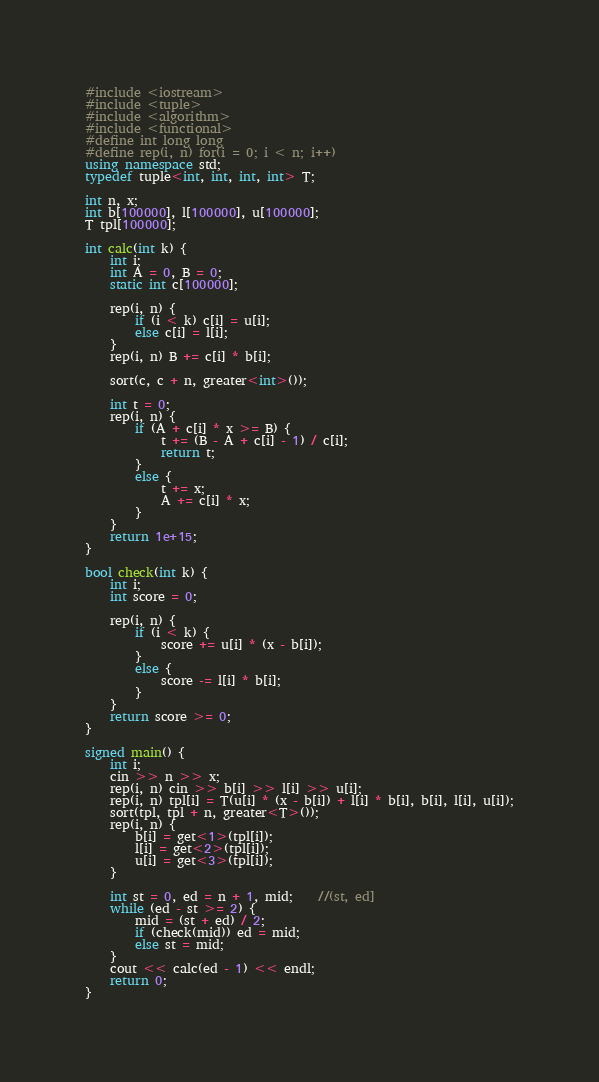Convert code to text. <code><loc_0><loc_0><loc_500><loc_500><_C++_>#include <iostream>
#include <tuple>
#include <algorithm>
#include <functional>
#define int long long
#define rep(i, n) for(i = 0; i < n; i++)
using namespace std;
typedef tuple<int, int, int, int> T;

int n, x;
int b[100000], l[100000], u[100000];
T tpl[100000];

int calc(int k) {
	int i;
	int A = 0, B = 0;
	static int c[100000];
	
	rep(i, n) {
		if (i < k) c[i] = u[i];
		else c[i] = l[i];
	}
	rep(i, n) B += c[i] * b[i];
	
	sort(c, c + n, greater<int>());
	
	int t = 0;
	rep(i, n) {
		if (A + c[i] * x >= B) {
			t += (B - A + c[i] - 1) / c[i];
			return t;
		}
		else {
			t += x;
			A += c[i] * x;
		}
	}
	return 1e+15;
}

bool check(int k) {
	int i;
	int score = 0;
	
	rep(i, n) {
		if (i < k) {
			score += u[i] * (x - b[i]);
		}
		else {
			score -= l[i] * b[i];
		}
	}
	return score >= 0;
}

signed main() {
	int i;
	cin >> n >> x;
	rep(i, n) cin >> b[i] >> l[i] >> u[i];
	rep(i, n) tpl[i] = T(u[i] * (x - b[i]) + l[i] * b[i], b[i], l[i], u[i]);
	sort(tpl, tpl + n, greater<T>());
	rep(i, n) {
		b[i] = get<1>(tpl[i]);
		l[i] = get<2>(tpl[i]);
		u[i] = get<3>(tpl[i]);
	}
	
	int st = 0, ed = n + 1, mid;	//(st, ed]
	while (ed - st >= 2) {
		mid = (st + ed) / 2;
		if (check(mid)) ed = mid;
		else st = mid;
	}
	cout << calc(ed - 1) << endl;
	return 0;
}</code> 